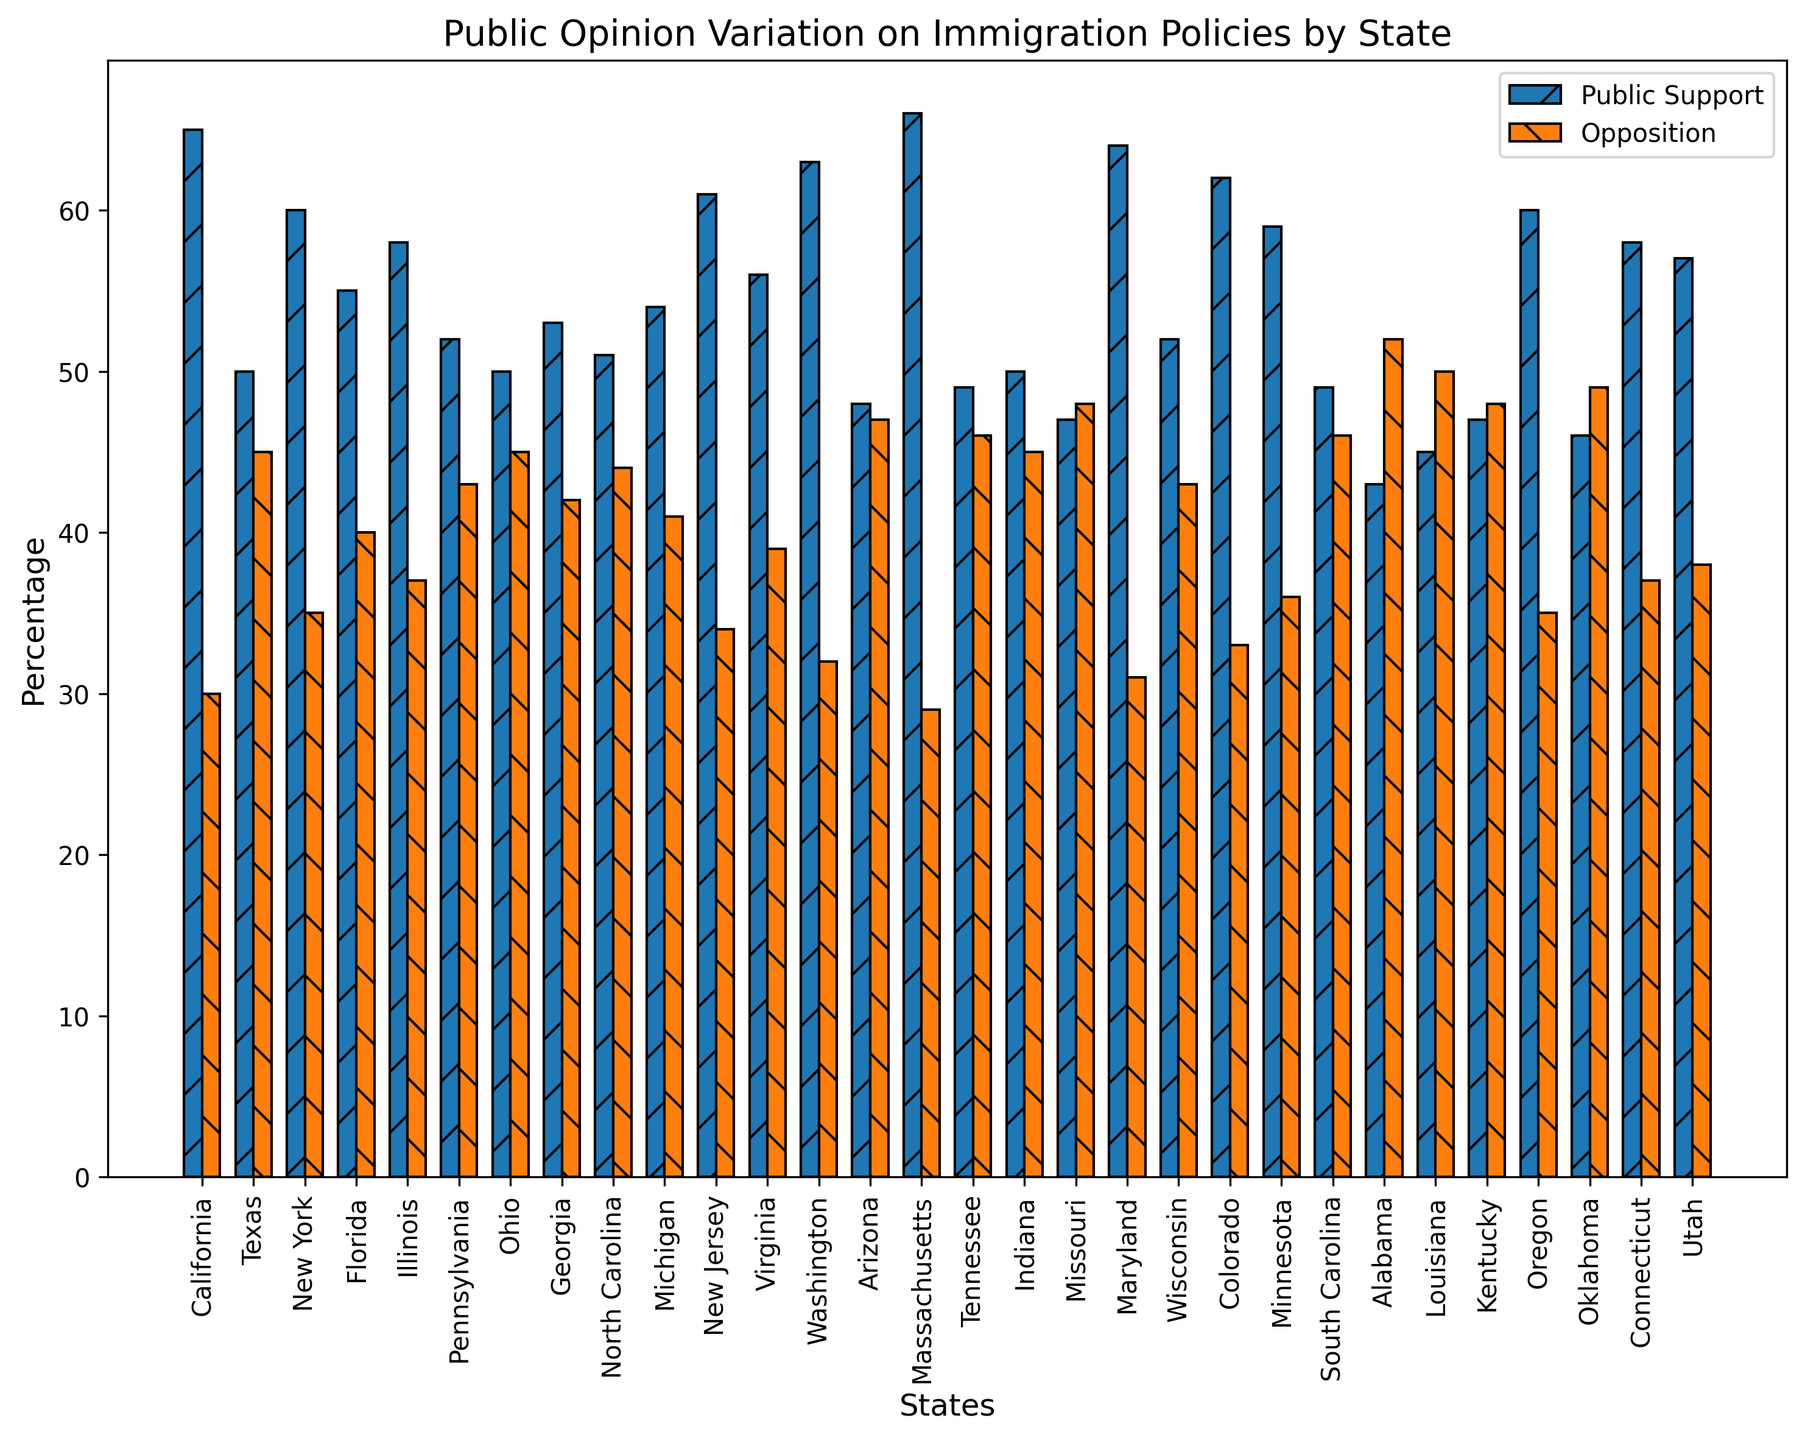What state has the highest public support percentage for immigration policies? From the bar chart, identify the bar with the greatest height representing public support. Massachusetts has the highest public support percentage of 66%.
Answer: Massachusetts What is the difference in public support percentages between California and Arizona? Subtract Arizona's public support percentage from California's public support percentage: 65% (California) - 48% (Arizona) = 17%.
Answer: 17% Which state has equal public support and opposition percentages? From the bar chart, identify the state where the heights of the support and opposition bars are equal. Ohio has both percentages at 50%.
Answer: Ohio Which state shows the greatest opposition to immigration policies, and what is the percentage? From the bar chart, identify the bar with the greatest height representing opposition. Alabama has the highest opposition percentage of 52%.
Answer: Alabama Which states have a public support percentage greater than 60%? From the bar chart, identify the states where the public support bar exceeds 60%. The states are California, Massachusetts, and Washington, Maryland, New Jersey, and Colorado.
Answer: California, Massachusetts, Washington, Maryland, New Jersey, Colorado How many percentage points higher is the public support in Massachusetts compared to the opposition in Texas? Subtract Texas's opposition percentage from Massachusetts's public support percentage: 66% (Massachusetts) - 45% (Texas) = 21%.
Answer: 21% Which state has the smallest gap between public support and opposition percentages, and what is the gap? Calculate the difference between the support and opposition percentages for each state. Tennessee has the smallest gap, with a difference of 3% (49% support - 46% opposition).
Answer: Tennessee, 3% Compare the opposition percentages between New York and Pennsylvania. Which is higher and by how much? Subtract Pennsylvania's opposition percentage from New York's opposition percentage: 43% (Pennsylvania) - 35% (New York) = 8%.
Answer: Pennsylvania, 8% Which states have opposition percentages over 45%? From the bar chart, identify the states where the opposition bar exceeds 45%. The states are Texas, Arizona, Tennessee, Indiana, Missouri, South Carolina, Alabama, Louisiana, Oklahoma.
Answer: Texas, Arizona, Tennessee, Indiana, Missouri, South Carolina, Alabama, Louisiana, Oklahoma 